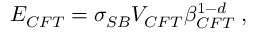Convert formula to latex. <formula><loc_0><loc_0><loc_500><loc_500>E _ { C F T } = \sigma _ { S B } V _ { C F T } \beta _ { C F T } ^ { 1 - d } \, ,</formula> 